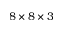Convert formula to latex. <formula><loc_0><loc_0><loc_500><loc_500>8 \times 8 \times 3</formula> 